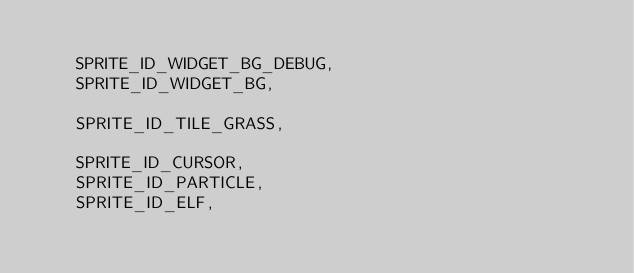Convert code to text. <code><loc_0><loc_0><loc_500><loc_500><_C++_>
    SPRITE_ID_WIDGET_BG_DEBUG,
    SPRITE_ID_WIDGET_BG,

    SPRITE_ID_TILE_GRASS,

    SPRITE_ID_CURSOR,
    SPRITE_ID_PARTICLE,
    SPRITE_ID_ELF,</code> 